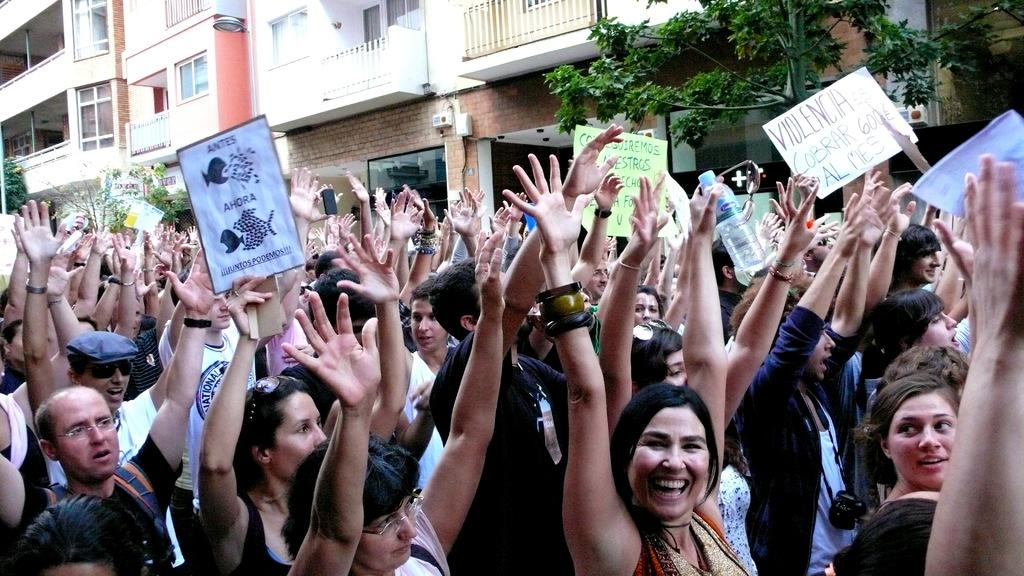What type of structure is visible in the image? There is a building in the image. Can you describe any specific features of the building? There is a balcony visible on the building. What are the people in the image doing? The group of people is standing in the image, holding placards in their hands. What else can be seen in the image besides the building and people? There is a tree in the image. What type of whip can be seen in the hands of the people in the image? There is no whip present in the image; the people are holding placards. Can you hear the sound of a whistle in the image? There is no sound present in the image, as it is a still photograph. 